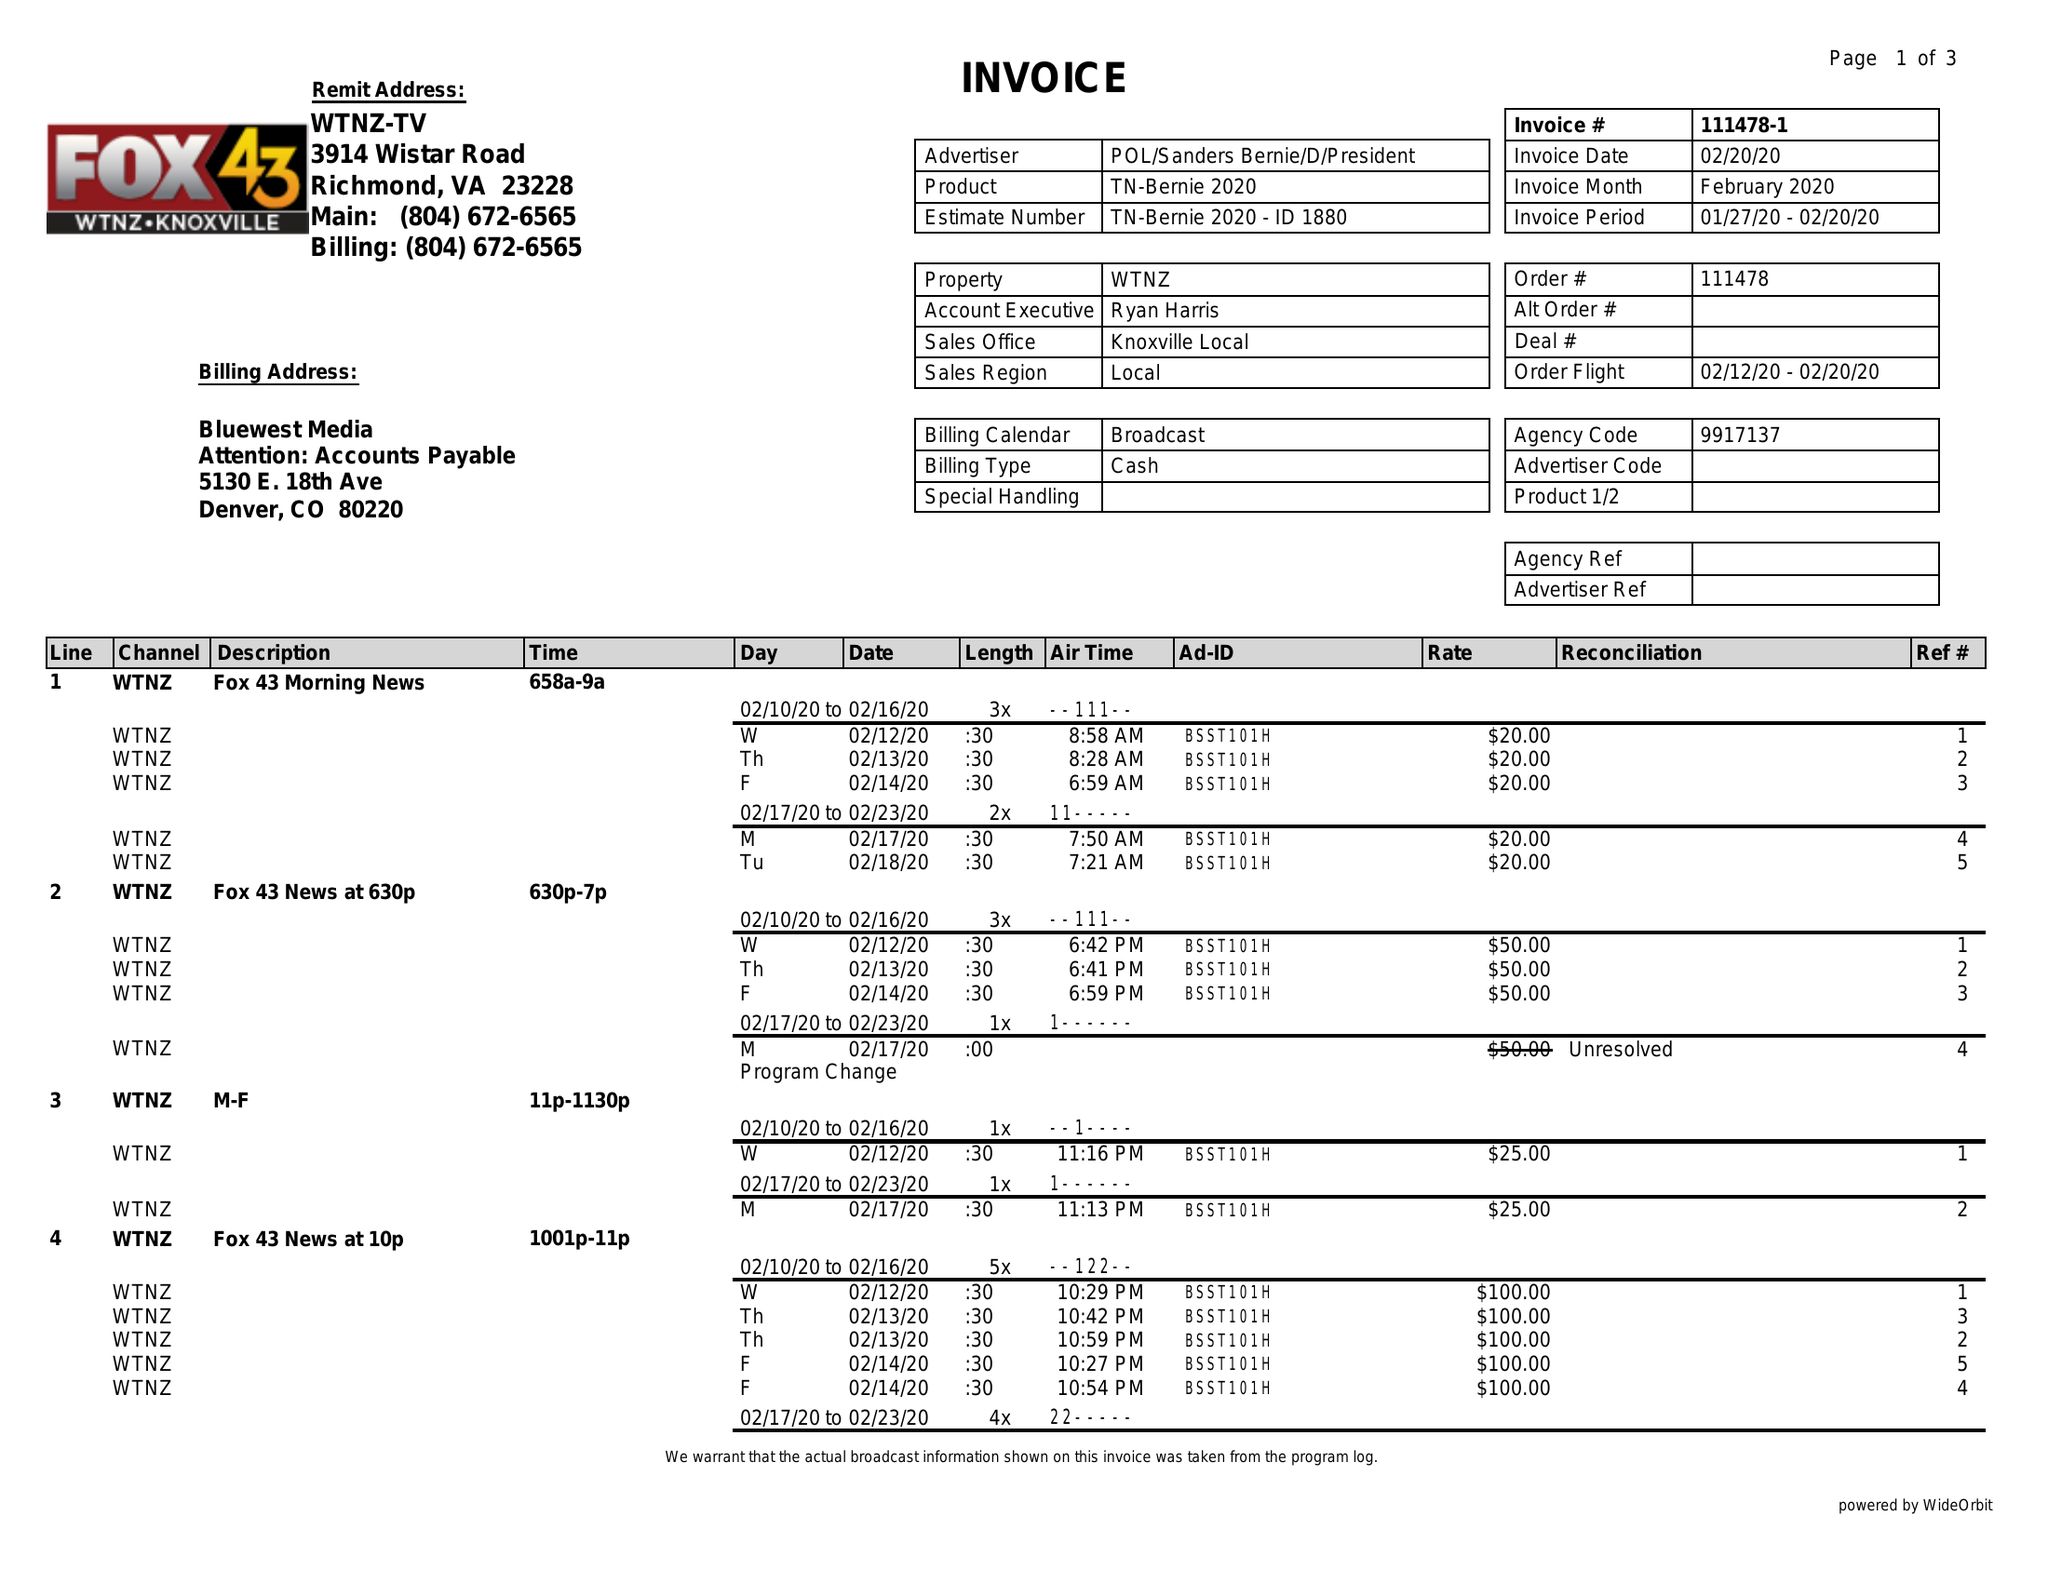What is the value for the flight_from?
Answer the question using a single word or phrase. 02/12/20 